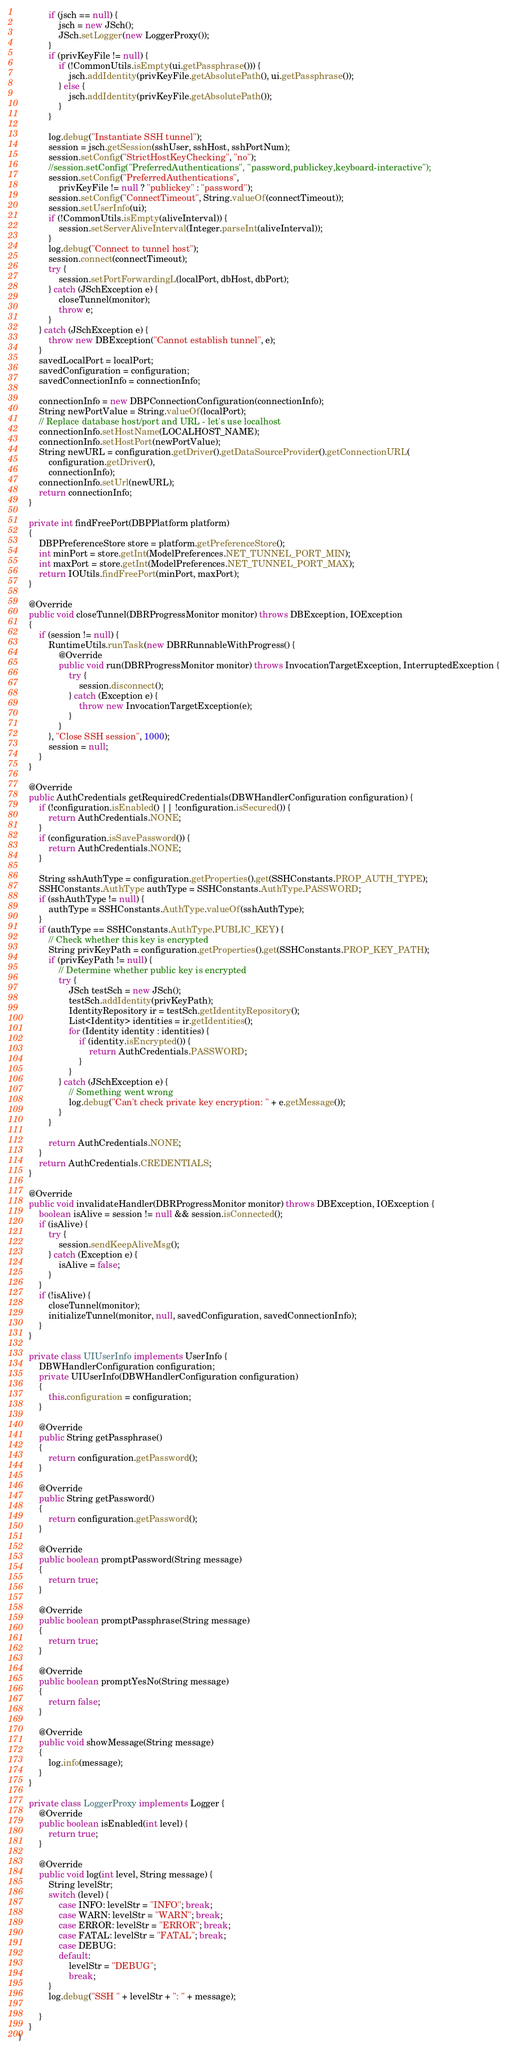Convert code to text. <code><loc_0><loc_0><loc_500><loc_500><_Java_>            if (jsch == null) {
                jsch = new JSch();
                JSch.setLogger(new LoggerProxy());
            }
            if (privKeyFile != null) {
                if (!CommonUtils.isEmpty(ui.getPassphrase())) {
                    jsch.addIdentity(privKeyFile.getAbsolutePath(), ui.getPassphrase());
                } else {
                    jsch.addIdentity(privKeyFile.getAbsolutePath());
                }
            }

            log.debug("Instantiate SSH tunnel");
            session = jsch.getSession(sshUser, sshHost, sshPortNum);
            session.setConfig("StrictHostKeyChecking", "no");
            //session.setConfig("PreferredAuthentications", "password,publickey,keyboard-interactive");
            session.setConfig("PreferredAuthentications",
                privKeyFile != null ? "publickey" : "password");
            session.setConfig("ConnectTimeout", String.valueOf(connectTimeout));
            session.setUserInfo(ui);
            if (!CommonUtils.isEmpty(aliveInterval)) {
                session.setServerAliveInterval(Integer.parseInt(aliveInterval));
            }
            log.debug("Connect to tunnel host");
            session.connect(connectTimeout);
            try {
                session.setPortForwardingL(localPort, dbHost, dbPort);
            } catch (JSchException e) {
                closeTunnel(monitor);
                throw e;
            }
        } catch (JSchException e) {
            throw new DBException("Cannot establish tunnel", e);
        }
        savedLocalPort = localPort;
        savedConfiguration = configuration;
        savedConnectionInfo = connectionInfo;

        connectionInfo = new DBPConnectionConfiguration(connectionInfo);
        String newPortValue = String.valueOf(localPort);
        // Replace database host/port and URL - let's use localhost
        connectionInfo.setHostName(LOCALHOST_NAME);
        connectionInfo.setHostPort(newPortValue);
        String newURL = configuration.getDriver().getDataSourceProvider().getConnectionURL(
            configuration.getDriver(),
            connectionInfo);
        connectionInfo.setUrl(newURL);
        return connectionInfo;
    }

    private int findFreePort(DBPPlatform platform)
    {
        DBPPreferenceStore store = platform.getPreferenceStore();
        int minPort = store.getInt(ModelPreferences.NET_TUNNEL_PORT_MIN);
        int maxPort = store.getInt(ModelPreferences.NET_TUNNEL_PORT_MAX);
        return IOUtils.findFreePort(minPort, maxPort);
    }

    @Override
    public void closeTunnel(DBRProgressMonitor monitor) throws DBException, IOException
    {
        if (session != null) {
            RuntimeUtils.runTask(new DBRRunnableWithProgress() {
                @Override
                public void run(DBRProgressMonitor monitor) throws InvocationTargetException, InterruptedException {
                    try {
                        session.disconnect();
                    } catch (Exception e) {
                        throw new InvocationTargetException(e);
                    }
                }
            }, "Close SSH session", 1000);
            session = null;
        }
    }

    @Override
    public AuthCredentials getRequiredCredentials(DBWHandlerConfiguration configuration) {
        if (!configuration.isEnabled() || !configuration.isSecured()) {
            return AuthCredentials.NONE;
        }
        if (configuration.isSavePassword()) {
            return AuthCredentials.NONE;
        }

        String sshAuthType = configuration.getProperties().get(SSHConstants.PROP_AUTH_TYPE);
        SSHConstants.AuthType authType = SSHConstants.AuthType.PASSWORD;
        if (sshAuthType != null) {
            authType = SSHConstants.AuthType.valueOf(sshAuthType);
        }
        if (authType == SSHConstants.AuthType.PUBLIC_KEY) {
            // Check whether this key is encrypted
            String privKeyPath = configuration.getProperties().get(SSHConstants.PROP_KEY_PATH);
            if (privKeyPath != null) {
                // Determine whether public key is encrypted
                try {
                    JSch testSch = new JSch();
                    testSch.addIdentity(privKeyPath);
                    IdentityRepository ir = testSch.getIdentityRepository();
                    List<Identity> identities = ir.getIdentities();
                    for (Identity identity : identities) {
                        if (identity.isEncrypted()) {
                            return AuthCredentials.PASSWORD;
                        }
                    }
                } catch (JSchException e) {
                    // Something went wrong
                    log.debug("Can't check private key encryption: " + e.getMessage());
                }
            }

            return AuthCredentials.NONE;
        }
        return AuthCredentials.CREDENTIALS;
    }

    @Override
    public void invalidateHandler(DBRProgressMonitor monitor) throws DBException, IOException {
        boolean isAlive = session != null && session.isConnected();
        if (isAlive) {
            try {
                session.sendKeepAliveMsg();
            } catch (Exception e) {
                isAlive = false;
            }
        }
        if (!isAlive) {
            closeTunnel(monitor);
            initializeTunnel(monitor, null, savedConfiguration, savedConnectionInfo);
        }
    }

    private class UIUserInfo implements UserInfo {
        DBWHandlerConfiguration configuration;
        private UIUserInfo(DBWHandlerConfiguration configuration)
        {
            this.configuration = configuration;
        }

        @Override
        public String getPassphrase()
        {
            return configuration.getPassword();
        }

        @Override
        public String getPassword()
        {
            return configuration.getPassword();
        }

        @Override
        public boolean promptPassword(String message)
        {
            return true;
        }

        @Override
        public boolean promptPassphrase(String message)
        {
            return true;
        }

        @Override
        public boolean promptYesNo(String message)
        {
            return false;
        }

        @Override
        public void showMessage(String message)
        {
            log.info(message);
        }
    }

    private class LoggerProxy implements Logger {
        @Override
        public boolean isEnabled(int level) {
            return true;
        }

        @Override
        public void log(int level, String message) {
            String levelStr;
            switch (level) {
                case INFO: levelStr = "INFO"; break;
                case WARN: levelStr = "WARN"; break;
                case ERROR: levelStr = "ERROR"; break;
                case FATAL: levelStr = "FATAL"; break;
                case DEBUG:
                default:
                    levelStr = "DEBUG";
                    break;
            }
            log.debug("SSH " + levelStr + ": " + message);

        }
    }
}
</code> 